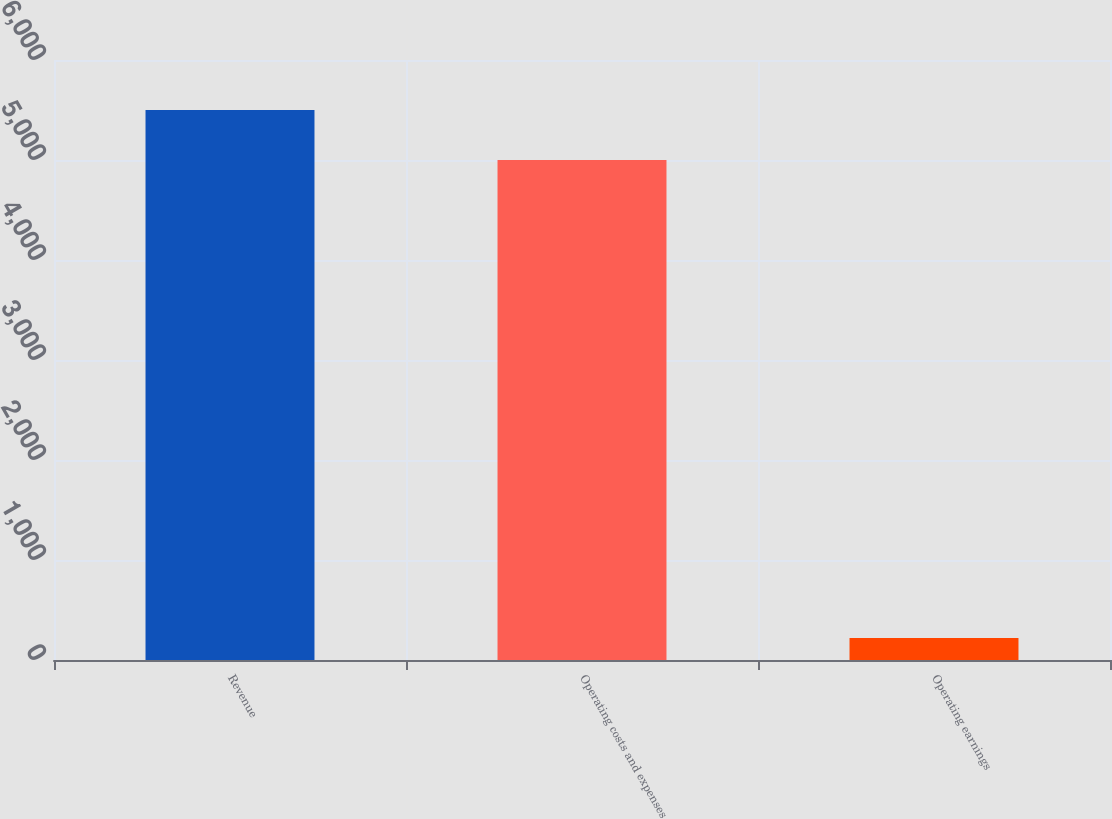<chart> <loc_0><loc_0><loc_500><loc_500><bar_chart><fcel>Revenue<fcel>Operating costs and expenses<fcel>Operating earnings<nl><fcel>5498.9<fcel>4999<fcel>221<nl></chart> 